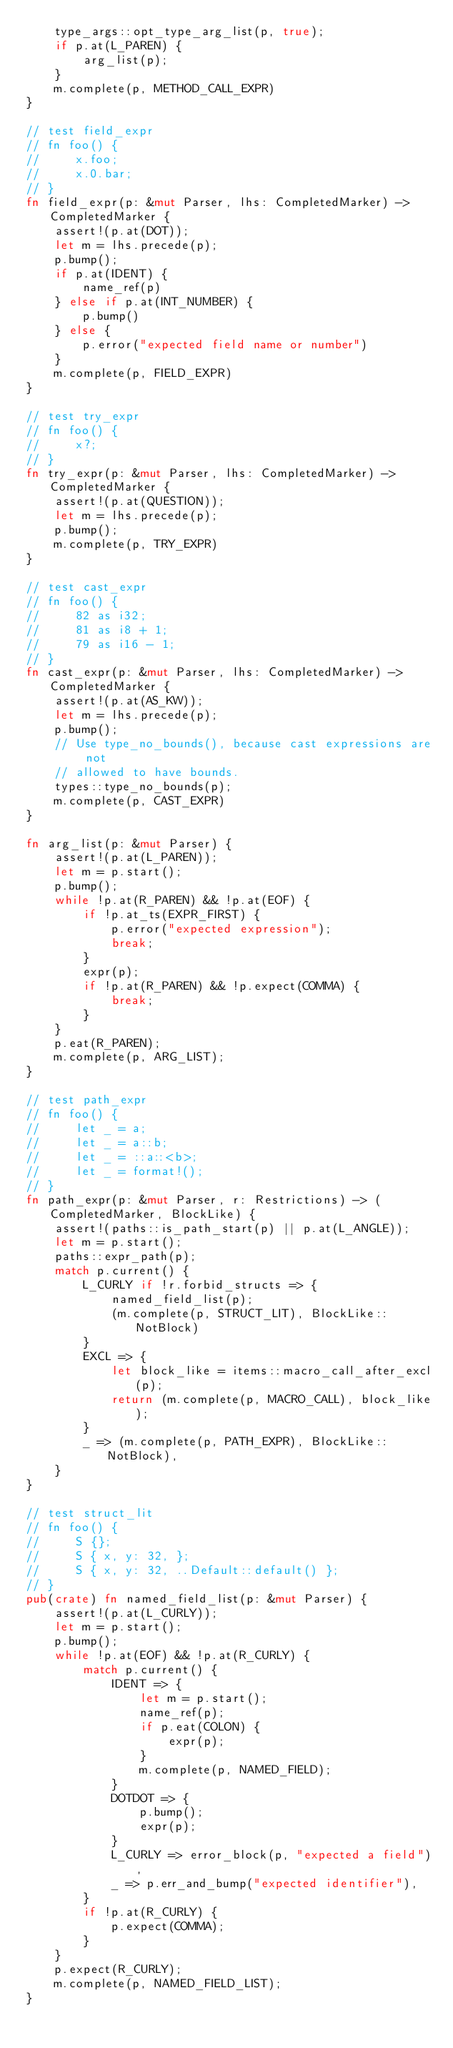Convert code to text. <code><loc_0><loc_0><loc_500><loc_500><_Rust_>    type_args::opt_type_arg_list(p, true);
    if p.at(L_PAREN) {
        arg_list(p);
    }
    m.complete(p, METHOD_CALL_EXPR)
}

// test field_expr
// fn foo() {
//     x.foo;
//     x.0.bar;
// }
fn field_expr(p: &mut Parser, lhs: CompletedMarker) -> CompletedMarker {
    assert!(p.at(DOT));
    let m = lhs.precede(p);
    p.bump();
    if p.at(IDENT) {
        name_ref(p)
    } else if p.at(INT_NUMBER) {
        p.bump()
    } else {
        p.error("expected field name or number")
    }
    m.complete(p, FIELD_EXPR)
}

// test try_expr
// fn foo() {
//     x?;
// }
fn try_expr(p: &mut Parser, lhs: CompletedMarker) -> CompletedMarker {
    assert!(p.at(QUESTION));
    let m = lhs.precede(p);
    p.bump();
    m.complete(p, TRY_EXPR)
}

// test cast_expr
// fn foo() {
//     82 as i32;
//     81 as i8 + 1;
//     79 as i16 - 1;
// }
fn cast_expr(p: &mut Parser, lhs: CompletedMarker) -> CompletedMarker {
    assert!(p.at(AS_KW));
    let m = lhs.precede(p);
    p.bump();
    // Use type_no_bounds(), because cast expressions are not
    // allowed to have bounds.
    types::type_no_bounds(p);
    m.complete(p, CAST_EXPR)
}

fn arg_list(p: &mut Parser) {
    assert!(p.at(L_PAREN));
    let m = p.start();
    p.bump();
    while !p.at(R_PAREN) && !p.at(EOF) {
        if !p.at_ts(EXPR_FIRST) {
            p.error("expected expression");
            break;
        }
        expr(p);
        if !p.at(R_PAREN) && !p.expect(COMMA) {
            break;
        }
    }
    p.eat(R_PAREN);
    m.complete(p, ARG_LIST);
}

// test path_expr
// fn foo() {
//     let _ = a;
//     let _ = a::b;
//     let _ = ::a::<b>;
//     let _ = format!();
// }
fn path_expr(p: &mut Parser, r: Restrictions) -> (CompletedMarker, BlockLike) {
    assert!(paths::is_path_start(p) || p.at(L_ANGLE));
    let m = p.start();
    paths::expr_path(p);
    match p.current() {
        L_CURLY if !r.forbid_structs => {
            named_field_list(p);
            (m.complete(p, STRUCT_LIT), BlockLike::NotBlock)
        }
        EXCL => {
            let block_like = items::macro_call_after_excl(p);
            return (m.complete(p, MACRO_CALL), block_like);
        }
        _ => (m.complete(p, PATH_EXPR), BlockLike::NotBlock),
    }
}

// test struct_lit
// fn foo() {
//     S {};
//     S { x, y: 32, };
//     S { x, y: 32, ..Default::default() };
// }
pub(crate) fn named_field_list(p: &mut Parser) {
    assert!(p.at(L_CURLY));
    let m = p.start();
    p.bump();
    while !p.at(EOF) && !p.at(R_CURLY) {
        match p.current() {
            IDENT => {
                let m = p.start();
                name_ref(p);
                if p.eat(COLON) {
                    expr(p);
                }
                m.complete(p, NAMED_FIELD);
            }
            DOTDOT => {
                p.bump();
                expr(p);
            }
            L_CURLY => error_block(p, "expected a field"),
            _ => p.err_and_bump("expected identifier"),
        }
        if !p.at(R_CURLY) {
            p.expect(COMMA);
        }
    }
    p.expect(R_CURLY);
    m.complete(p, NAMED_FIELD_LIST);
}
</code> 